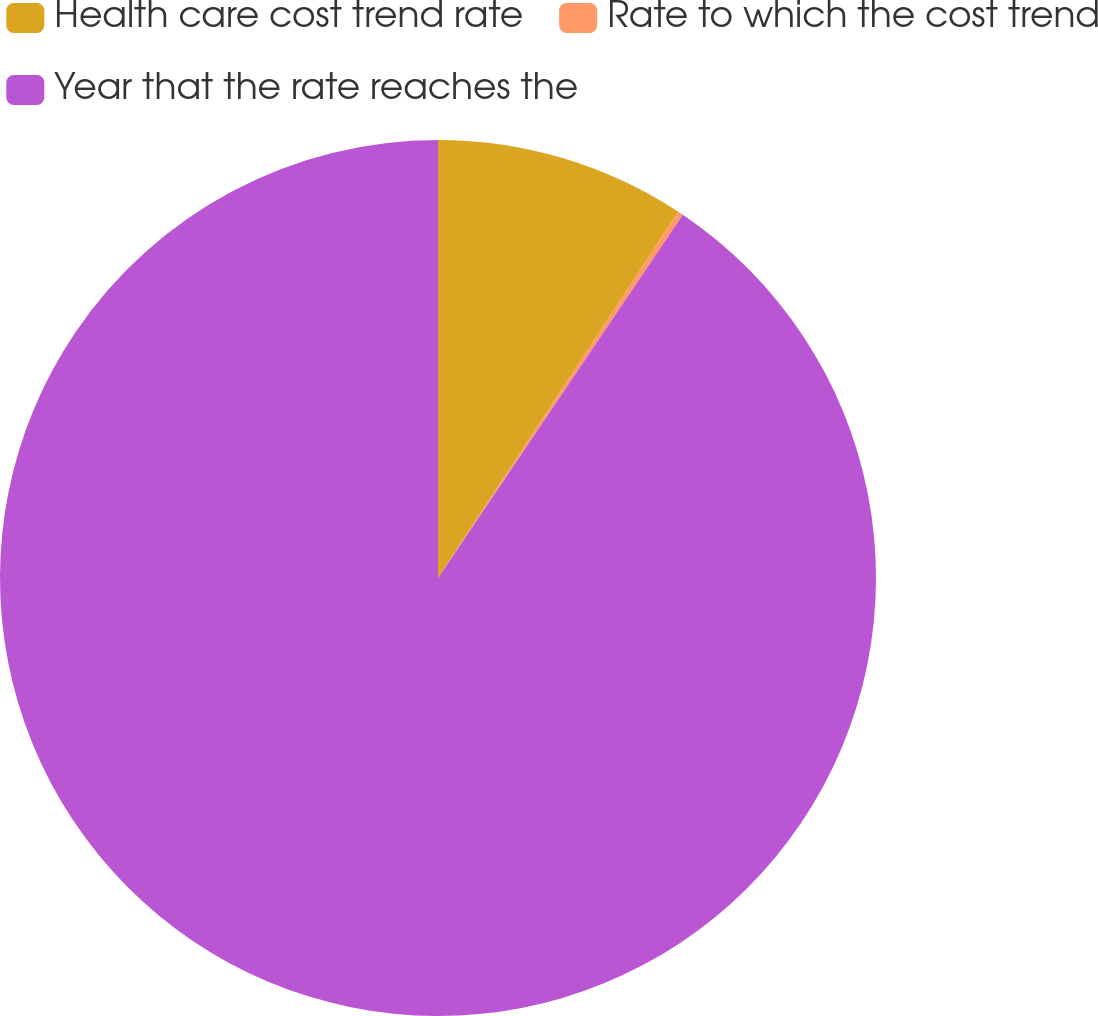Convert chart. <chart><loc_0><loc_0><loc_500><loc_500><pie_chart><fcel>Health care cost trend rate<fcel>Rate to which the cost trend<fcel>Year that the rate reaches the<nl><fcel>9.24%<fcel>0.2%<fcel>90.56%<nl></chart> 